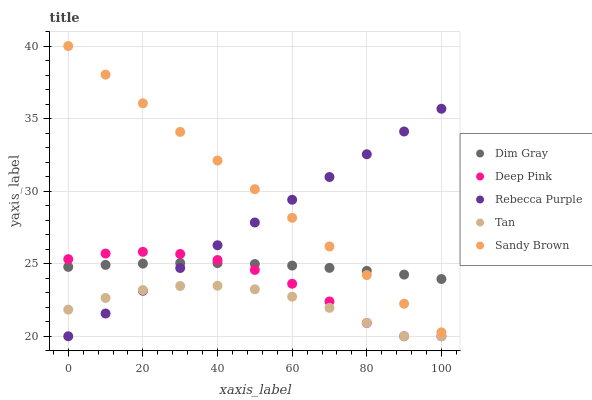Does Tan have the minimum area under the curve?
Answer yes or no. Yes. Does Sandy Brown have the maximum area under the curve?
Answer yes or no. Yes. Does Dim Gray have the minimum area under the curve?
Answer yes or no. No. Does Dim Gray have the maximum area under the curve?
Answer yes or no. No. Is Sandy Brown the smoothest?
Answer yes or no. Yes. Is Deep Pink the roughest?
Answer yes or no. Yes. Is Dim Gray the smoothest?
Answer yes or no. No. Is Dim Gray the roughest?
Answer yes or no. No. Does Tan have the lowest value?
Answer yes or no. Yes. Does Sandy Brown have the lowest value?
Answer yes or no. No. Does Sandy Brown have the highest value?
Answer yes or no. Yes. Does Dim Gray have the highest value?
Answer yes or no. No. Is Tan less than Sandy Brown?
Answer yes or no. Yes. Is Sandy Brown greater than Deep Pink?
Answer yes or no. Yes. Does Sandy Brown intersect Dim Gray?
Answer yes or no. Yes. Is Sandy Brown less than Dim Gray?
Answer yes or no. No. Is Sandy Brown greater than Dim Gray?
Answer yes or no. No. Does Tan intersect Sandy Brown?
Answer yes or no. No. 